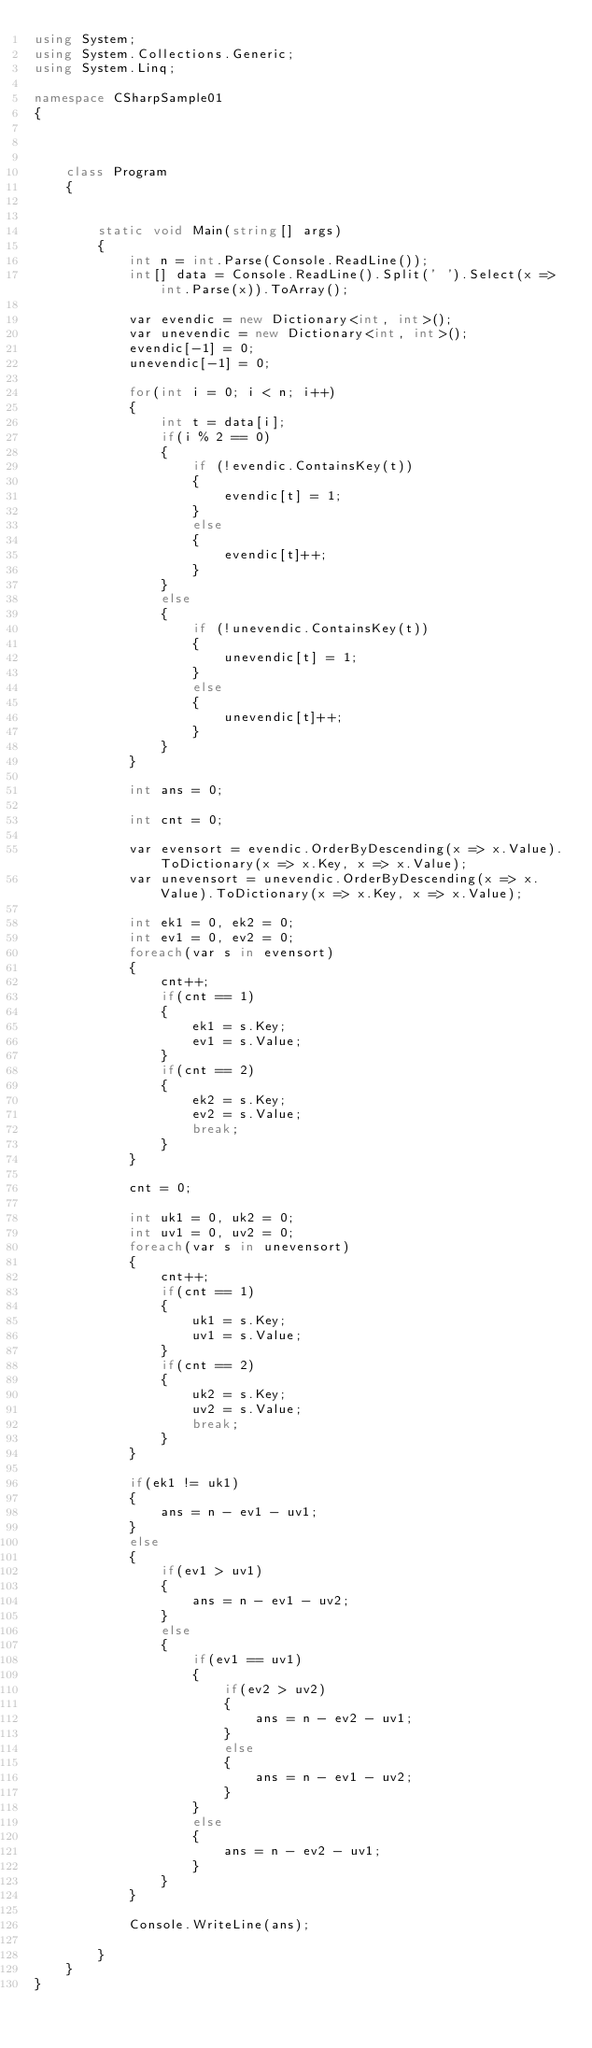Convert code to text. <code><loc_0><loc_0><loc_500><loc_500><_C#_>using System;
using System.Collections.Generic;
using System.Linq;

namespace CSharpSample01
{

    

    class Program
    {

        
        static void Main(string[] args)
        {
            int n = int.Parse(Console.ReadLine());
            int[] data = Console.ReadLine().Split(' ').Select(x => int.Parse(x)).ToArray();

            var evendic = new Dictionary<int, int>();
            var unevendic = new Dictionary<int, int>();
            evendic[-1] = 0;
            unevendic[-1] = 0;

            for(int i = 0; i < n; i++)
            {
                int t = data[i];
                if(i % 2 == 0)
                {
                    if (!evendic.ContainsKey(t))
                    {
                        evendic[t] = 1;
                    }
                    else
                    {
                        evendic[t]++;
                    }
                }
                else
                {
                    if (!unevendic.ContainsKey(t))
                    {
                        unevendic[t] = 1;
                    }
                    else
                    {
                        unevendic[t]++;
                    }
                }
            }

            int ans = 0;         
            
            int cnt = 0;

            var evensort = evendic.OrderByDescending(x => x.Value).ToDictionary(x => x.Key, x => x.Value);
            var unevensort = unevendic.OrderByDescending(x => x.Value).ToDictionary(x => x.Key, x => x.Value);

            int ek1 = 0, ek2 = 0;
            int ev1 = 0, ev2 = 0;
            foreach(var s in evensort)
            {
                cnt++;
                if(cnt == 1)
                {
                    ek1 = s.Key;
                    ev1 = s.Value;
                }
                if(cnt == 2)
                {
                    ek2 = s.Key;
                    ev2 = s.Value;
                    break;
                }
            }

            cnt = 0;

            int uk1 = 0, uk2 = 0;
            int uv1 = 0, uv2 = 0;
            foreach(var s in unevensort)
            {
                cnt++;
                if(cnt == 1)
                {
                    uk1 = s.Key;
                    uv1 = s.Value;
                }
                if(cnt == 2)
                {
                    uk2 = s.Key;
                    uv2 = s.Value;
                    break;
                }
            }
            
            if(ek1 != uk1)
            {
                ans = n - ev1 - uv1;
            }
            else
            {
                if(ev1 > uv1)
                {
                    ans = n - ev1 - uv2;
                }
                else
                {
                    if(ev1 == uv1)
                    {
                        if(ev2 > uv2)
                        {
                            ans = n - ev2 - uv1;
                        }
                        else
                        {
                            ans = n - ev1 - uv2;
                        }
                    }
                    else
                    {
                        ans = n - ev2 - uv1;
                    }
                }
            }
            
            Console.WriteLine(ans);

        }
    }
}
</code> 